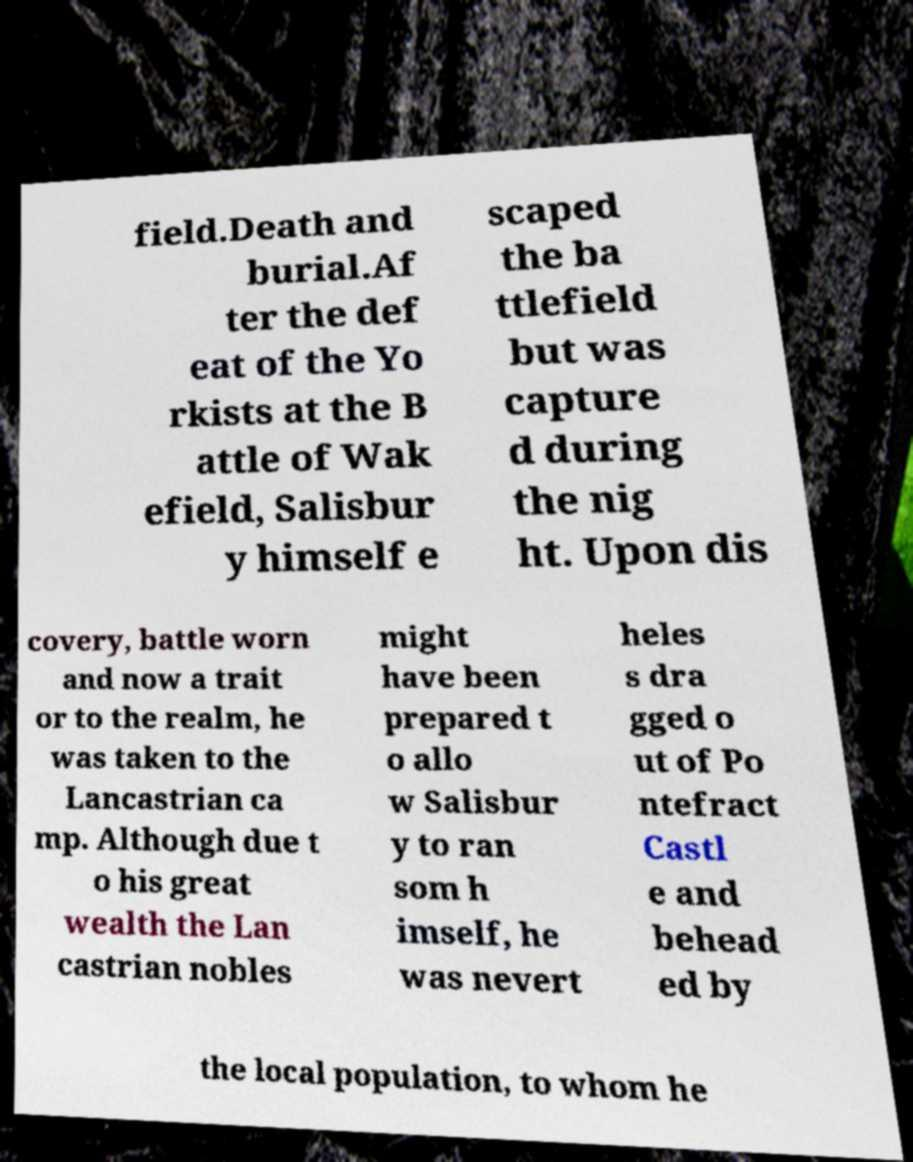Please identify and transcribe the text found in this image. field.Death and burial.Af ter the def eat of the Yo rkists at the B attle of Wak efield, Salisbur y himself e scaped the ba ttlefield but was capture d during the nig ht. Upon dis covery, battle worn and now a trait or to the realm, he was taken to the Lancastrian ca mp. Although due t o his great wealth the Lan castrian nobles might have been prepared t o allo w Salisbur y to ran som h imself, he was nevert heles s dra gged o ut of Po ntefract Castl e and behead ed by the local population, to whom he 